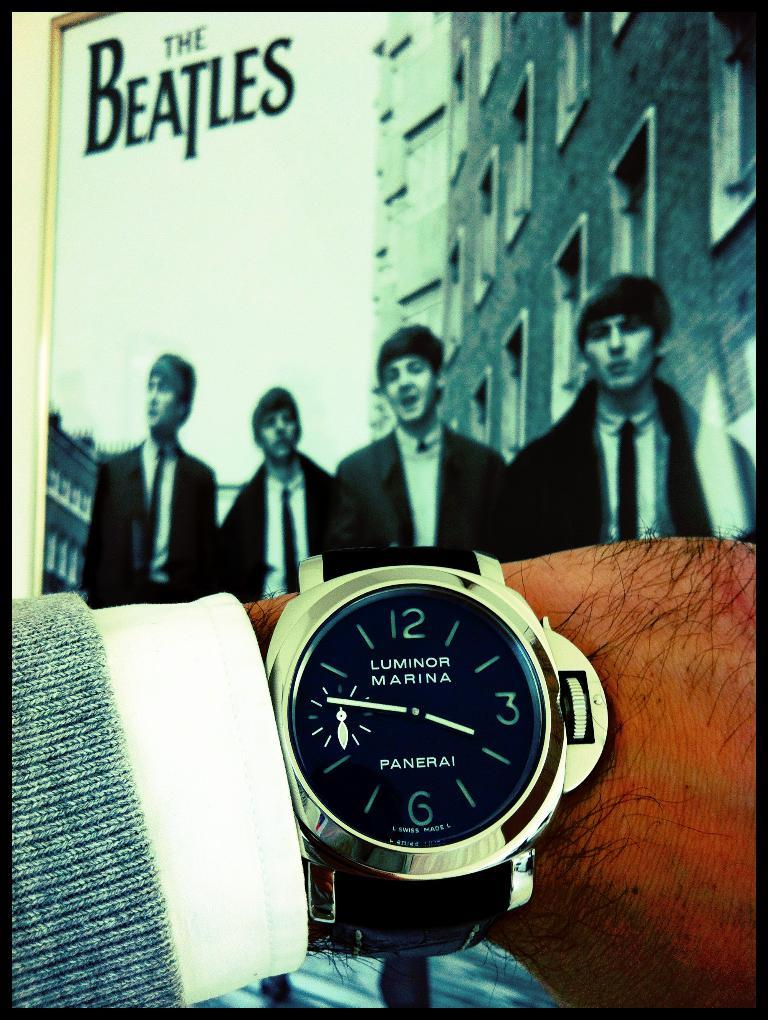What object is on a hand in the image? There is a watch on a hand in the image. What can be seen in the background of the image? There is a photo frame in the background of the image, which contains a picture of four boys. What else is visible in the background of the image? There are buildings visible in the background of the image. Can you tell me how many times the watch has been bitten in the image? There is no indication in the image that the watch has been bitten, so it cannot be determined from the picture. 